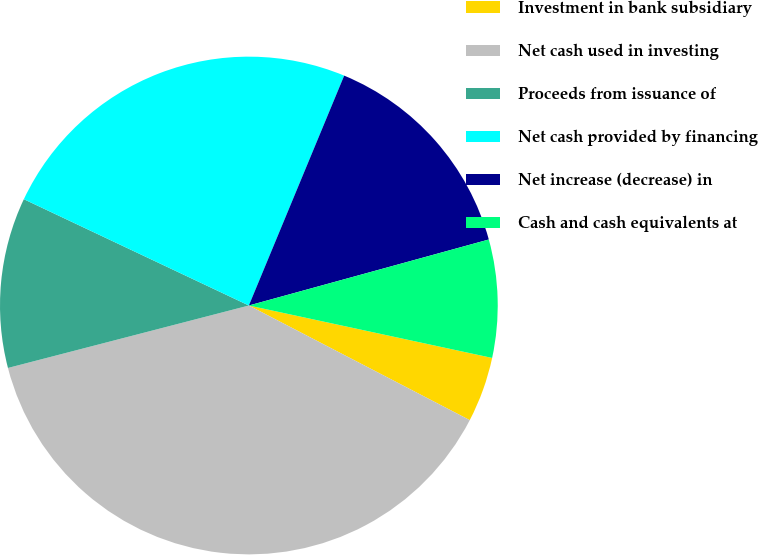<chart> <loc_0><loc_0><loc_500><loc_500><pie_chart><fcel>Investment in bank subsidiary<fcel>Net cash used in investing<fcel>Proceeds from issuance of<fcel>Net cash provided by financing<fcel>Net increase (decrease) in<fcel>Cash and cash equivalents at<nl><fcel>4.24%<fcel>38.34%<fcel>11.06%<fcel>24.23%<fcel>14.47%<fcel>7.65%<nl></chart> 